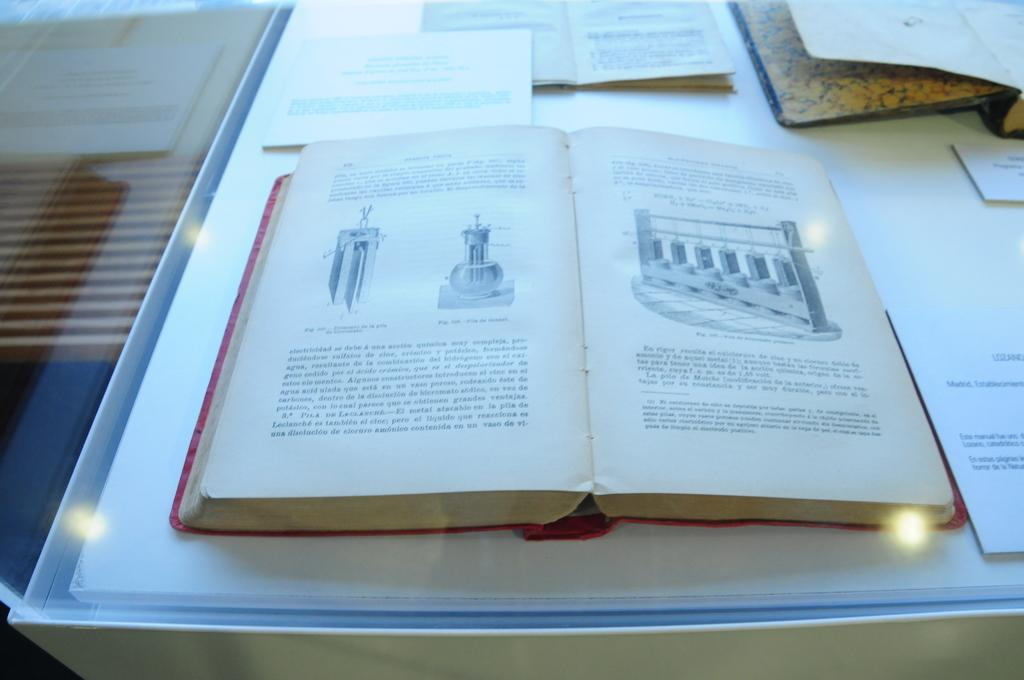What is the main subject in the center of the image? There is an open book in the center of the image. Are there any other books visible in the image? Yes, there are other books at the top side of the image. What is the surface on which the books are placed? The books are on a glass table. Where are the scissors located in the image? There are no scissors present in the image. What type of cup is being used to hold the books in the image? There is no cup present in the image; the books are on a glass table. 